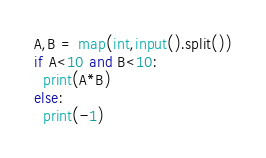<code> <loc_0><loc_0><loc_500><loc_500><_Python_>A,B = map(int,input().split())
if A<10 and B<10:
  print(A*B)
else:
  print(-1)
</code> 